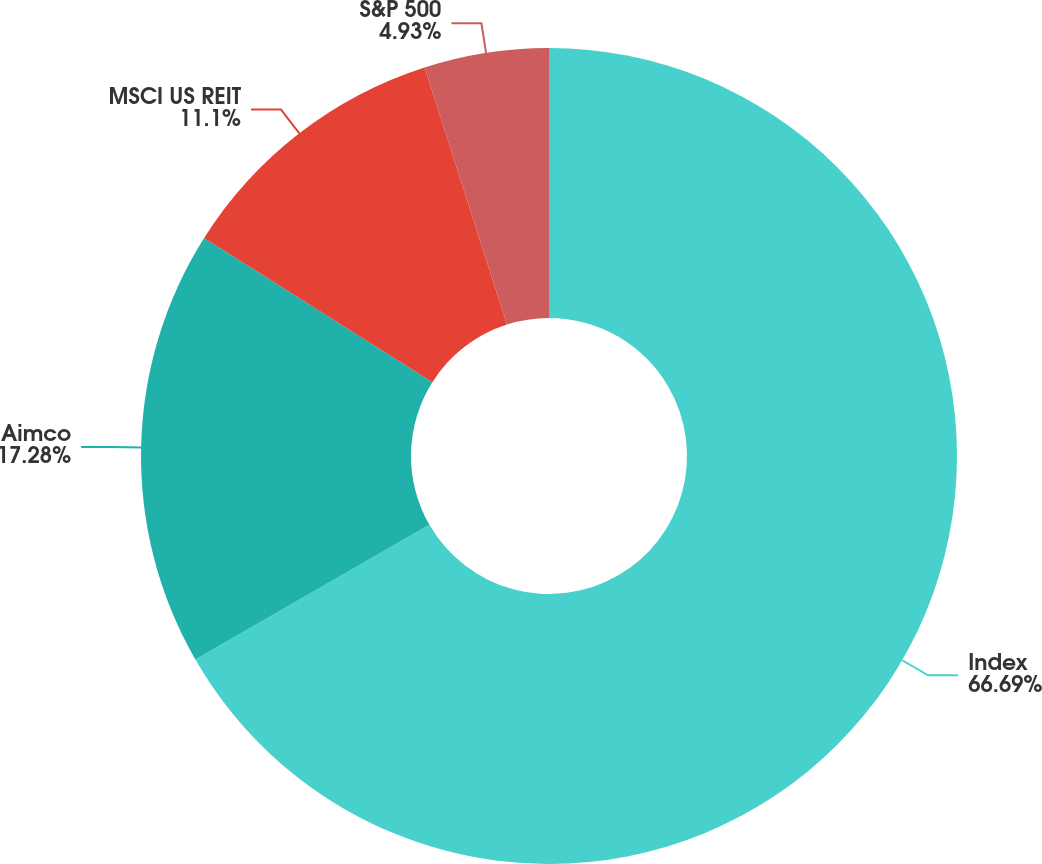Convert chart to OTSL. <chart><loc_0><loc_0><loc_500><loc_500><pie_chart><fcel>Index<fcel>Aimco<fcel>MSCI US REIT<fcel>S&P 500<nl><fcel>66.69%<fcel>17.28%<fcel>11.1%<fcel>4.93%<nl></chart> 